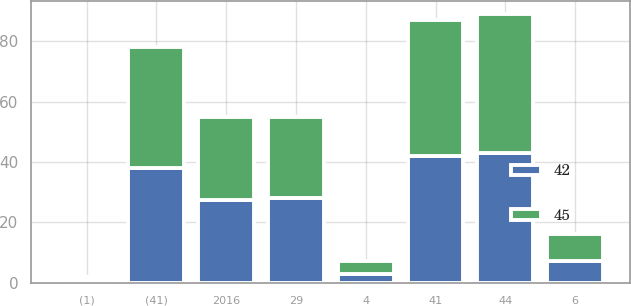Convert chart to OTSL. <chart><loc_0><loc_0><loc_500><loc_500><stacked_bar_chart><ecel><fcel>2016<fcel>44<fcel>29<fcel>(41)<fcel>(1)<fcel>6<fcel>4<fcel>41<nl><fcel>45<fcel>27.5<fcel>46<fcel>27<fcel>40<fcel>1<fcel>9<fcel>4<fcel>45<nl><fcel>42<fcel>27.5<fcel>43<fcel>28<fcel>38<fcel>1<fcel>7<fcel>3<fcel>42<nl></chart> 